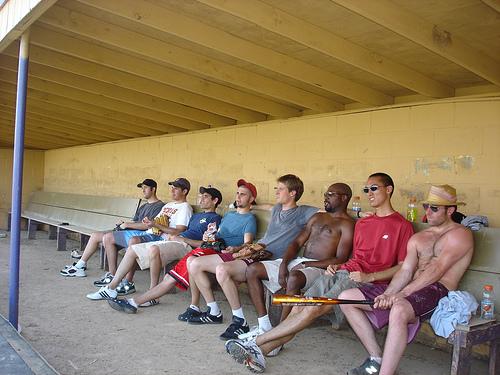Is the room yellow?
Give a very brief answer. Yes. How many men are wearing hats?
Quick response, please. 5. How many guys are wearing glasses?
Quick response, please. 3. Are all the people holding each other's hands?
Quick response, please. No. 